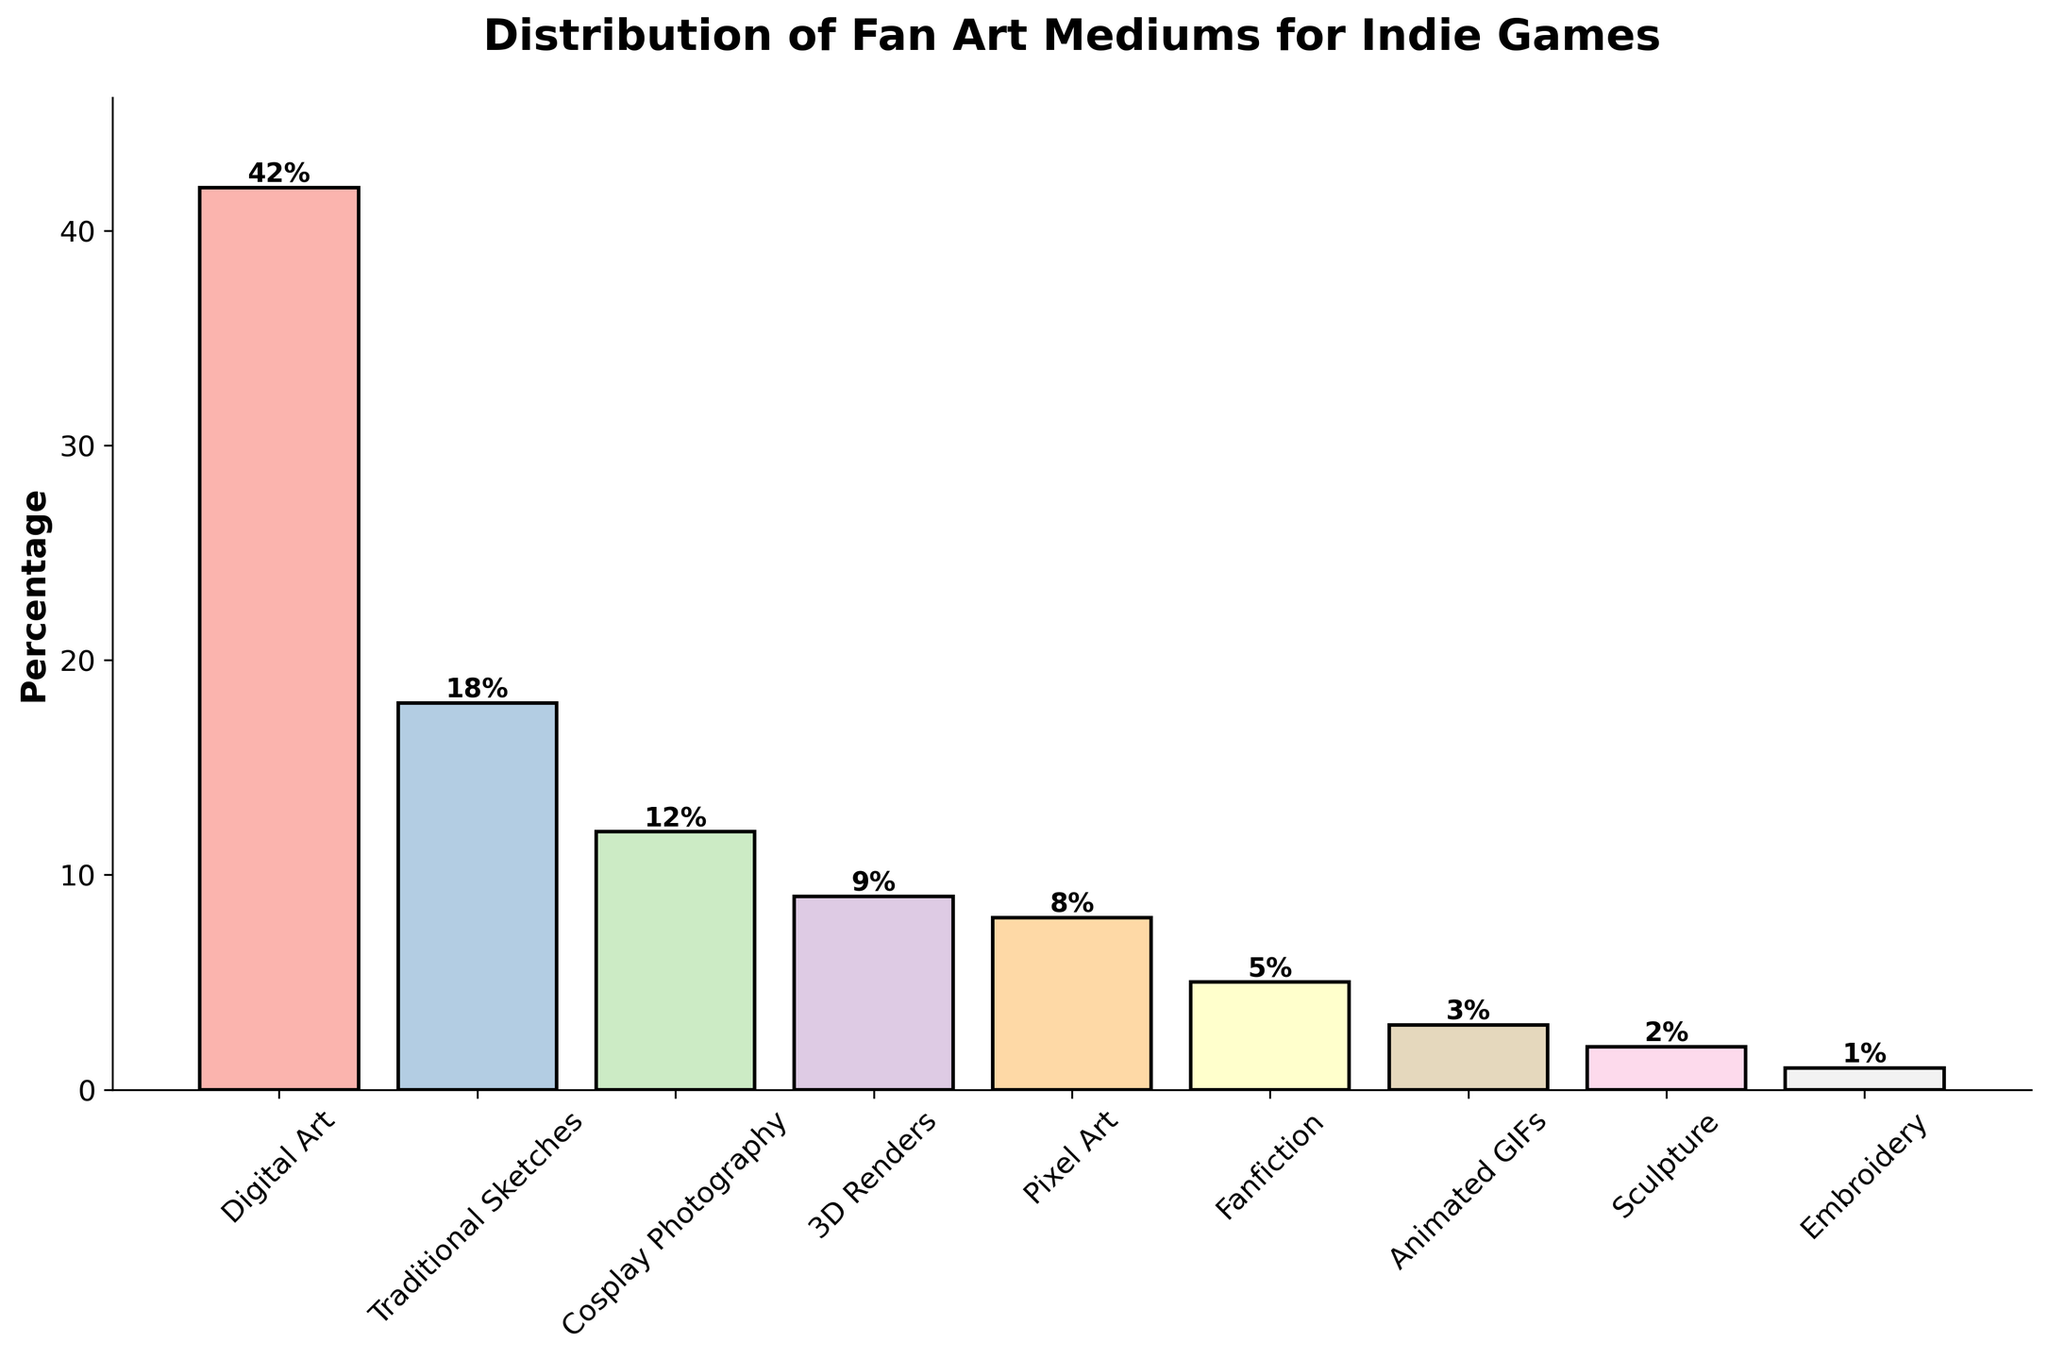Which medium has the highest percentage of fan art? We can see the tallest bar in the bar chart represents Digital Art with a percentage value at its top.
Answer: Digital Art What is the combined percentage of Traditional Sketches and Cosplay Photography? Traditional Sketches has a percentage of 18, and Cosplay Photography has a percentage of 12. Add them together: 18 + 12 = 30.
Answer: 30 Is the percentage of Digital Art greater than 3D Renders and Fanfiction combined? Digital Art has a percentage of 42. Both 3D Renders and Fanfiction have percentages of 9 and 5, respectively. Adding 3D Renders and Fanfiction gives 9 + 5 = 14, which is less than 42.
Answer: Yes Which mediums have percentages less than 5? By examining the bar chart, we observe that Animated GIFs, Sculpture, and Embroidery have percentages of 3, 2, and 1, respectively, all of which are less than 5.
Answer: Animated GIFs, Sculpture, Embroidery What's the difference in percentage between the medium with the highest percentage and the medium with the lowest percentage? The highest percentage is for Digital Art at 42, and the lowest is for Embroidery at 1. The difference is calculated as 42 - 1 = 41.
Answer: 41 Arrange the mediums in descending order of their percentages. From the bars' heights, the ordered mediums are: Digital Art, Traditional Sketches, Cosplay Photography, 3D Renders, Pixel Art, Fanfiction, Animated GIFs, Sculpture, Embroidery.
Answer: Digital Art, Traditional Sketches, Cosplay Photography, 3D Renders, Pixel Art, Fanfiction, Animated GIFs, Sculpture, Embroidery Does Fanfiction have a greater percentage than Pixel Art? Fanfiction has a percentage of 5, while Pixel Art has a percentage of 8. From this, it’s clear that 5 is less than 8.
Answer: No What is the percentage range of the top three mediums? The top three mediums are Digital Art (42), Traditional Sketches (18), and Cosplay Photography (12). The range is found by subtracting the smallest value among the three from the largest: 42 - 12 = 30.
Answer: 30 